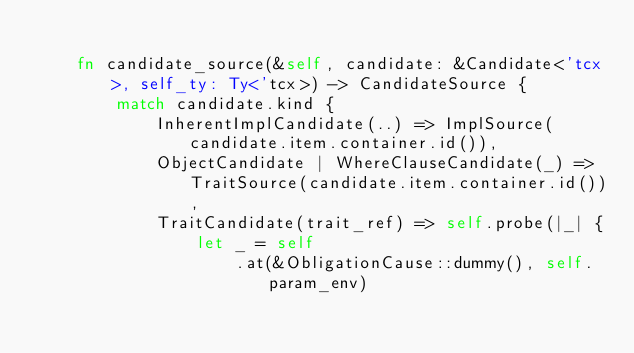Convert code to text. <code><loc_0><loc_0><loc_500><loc_500><_Rust_>
    fn candidate_source(&self, candidate: &Candidate<'tcx>, self_ty: Ty<'tcx>) -> CandidateSource {
        match candidate.kind {
            InherentImplCandidate(..) => ImplSource(candidate.item.container.id()),
            ObjectCandidate | WhereClauseCandidate(_) => TraitSource(candidate.item.container.id()),
            TraitCandidate(trait_ref) => self.probe(|_| {
                let _ = self
                    .at(&ObligationCause::dummy(), self.param_env)</code> 